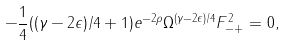Convert formula to latex. <formula><loc_0><loc_0><loc_500><loc_500>- \frac { 1 } { 4 } ( ( \gamma - 2 \epsilon ) / 4 + 1 ) e ^ { - 2 \rho } \Omega ^ { ( \gamma - 2 \epsilon ) / 4 } F ^ { 2 } _ { - + } = 0 ,</formula> 